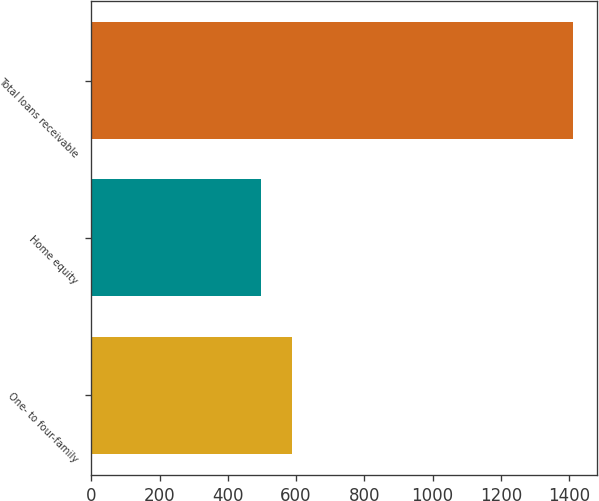Convert chart to OTSL. <chart><loc_0><loc_0><loc_500><loc_500><bar_chart><fcel>One- to four-family<fcel>Home equity<fcel>Total loans receivable<nl><fcel>589.4<fcel>498<fcel>1412<nl></chart> 